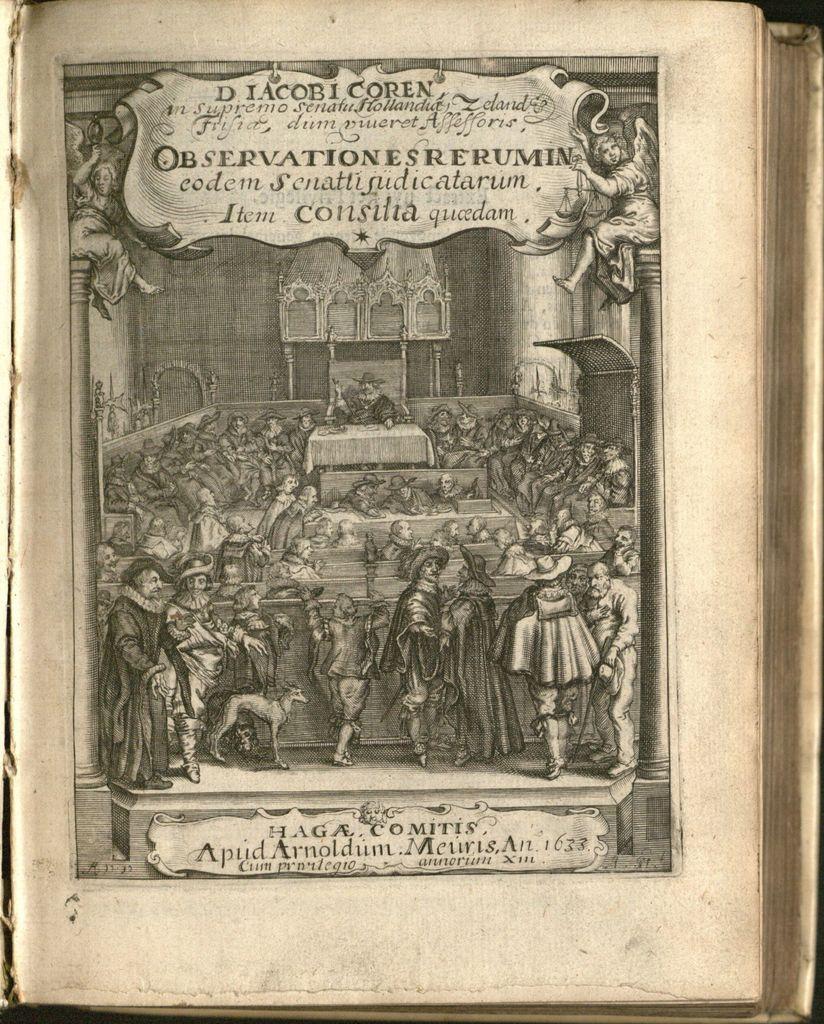When was this created?
Make the answer very short. 1633. 